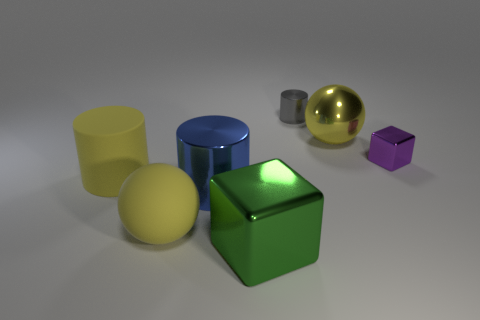There is a metal cylinder left of the big green shiny thing; is it the same color as the big sphere that is behind the yellow cylinder?
Offer a terse response. No. Is the number of purple shiny things in front of the large yellow matte cylinder greater than the number of purple metal things that are behind the large yellow metallic ball?
Provide a short and direct response. No. There is another thing that is the same shape as the green shiny thing; what is its color?
Ensure brevity in your answer.  Purple. Are there any other things that are the same shape as the green shiny object?
Your answer should be very brief. Yes. Does the blue thing have the same shape as the matte thing left of the large yellow matte ball?
Provide a succinct answer. Yes. How many other objects are there of the same material as the tiny gray object?
Your response must be concise. 4. Does the rubber sphere have the same color as the large sphere that is to the right of the big green metal object?
Give a very brief answer. Yes. There is a block that is on the left side of the big yellow shiny sphere; what is it made of?
Make the answer very short. Metal. Are there any objects of the same color as the shiny sphere?
Give a very brief answer. Yes. What color is the other thing that is the same size as the gray metallic object?
Ensure brevity in your answer.  Purple. 